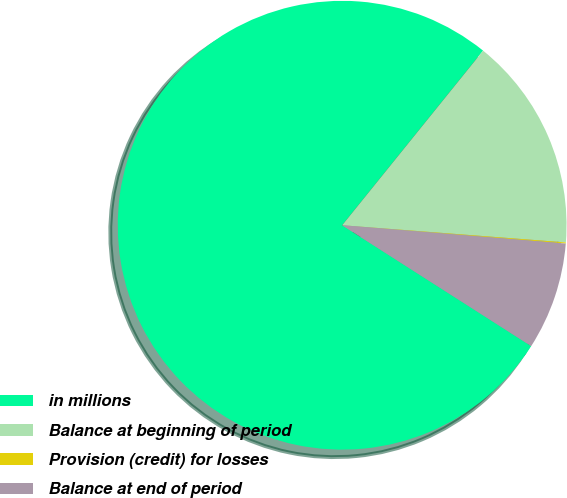Convert chart to OTSL. <chart><loc_0><loc_0><loc_500><loc_500><pie_chart><fcel>in millions<fcel>Balance at beginning of period<fcel>Provision (credit) for losses<fcel>Balance at end of period<nl><fcel>76.76%<fcel>15.41%<fcel>0.08%<fcel>7.75%<nl></chart> 